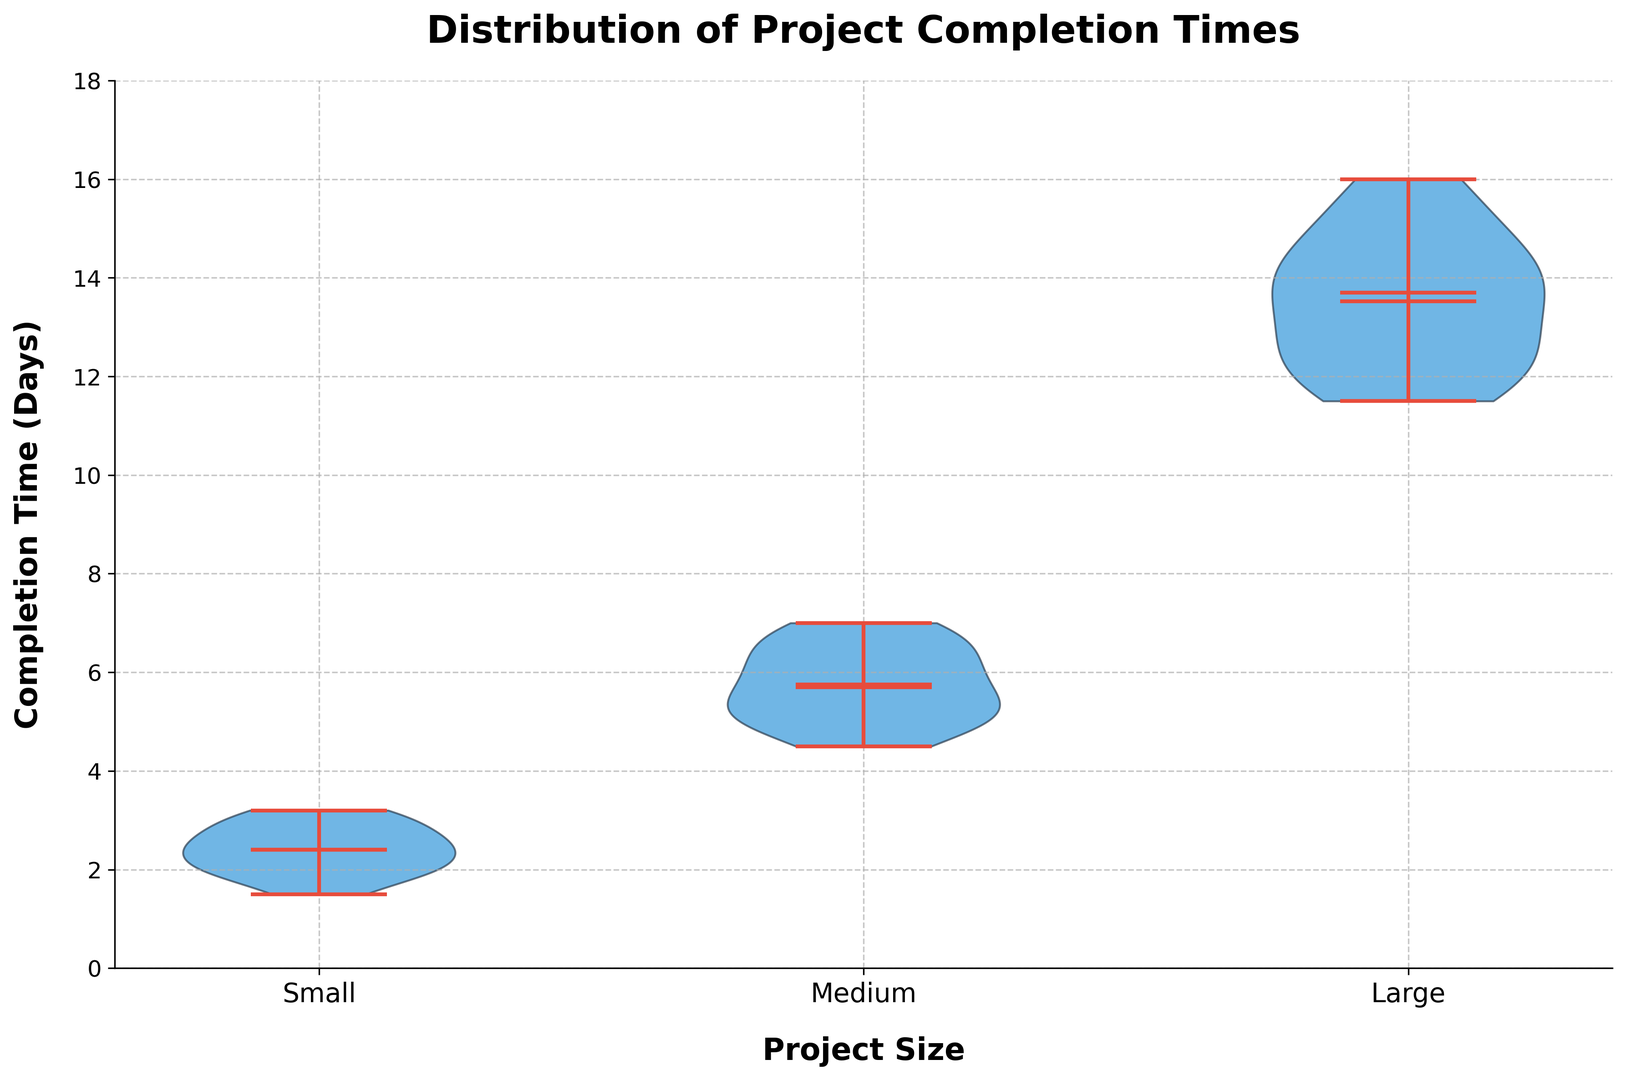What is the median completion time for medium-sized projects? The median is represented by the line shown in the middle of the distribution for medium-sized projects. This is visibly located around 6 days.
Answer: 6 Which project size has the greatest range in completion times? The range in completion times can be seen by looking at the length from the minimum to the maximum extent of each violin plot. The large-scale projects have the greatest range, spanning from around 11 to 16 days.
Answer: Large Are the mean and median completion times for small projects roughly equal? The mean is represented by a dot and the median by the line within the violin plot. For small projects, both indicators are placed very close to each other around 2.5 days, suggesting they are roughly equal.
Answer: Yes How do the completion times for medium projects compare to small projects in terms of variability? The variability can be seen by the spread of the violin plot. Medium projects have a wider spread than small projects, indicating greater variability in completion times.
Answer: Medium projects have greater variability Which project size has the smallest interquartile range (IQR)? The IQR can be visually approximated by the width of the middle part of the violin plot. Small-sized projects show a more concentrated, narrow middle region compared to medium and large projects, indicating a smaller IQR.
Answer: Small What can you conclude about the distribution shapes for each project size? Small projects have a roughly symmetric, normal-like distribution, medium projects have a slightly right-skewed distribution, and large projects have a multimodal distribution with a bimodal tendency.
Answer: Small: symmetric, Medium: right-skewed, Large: bimodal Compare the highest completion times for small and medium projects. The maximum completion time for small projects is around 3.2 days, while for medium projects, it is about 7 days.
Answer: Medium projects have a higher maximum How does the spread of completion times for large projects compare to that of small projects? The spread of completion times is shown by the width of the entire violin plot. Large projects have a much broader spread than small projects, indicating larger variability in completion times for large projects.
Answer: Large projects have a broader spread What percentage of small projects are completed under 2 days? The lower portion of the small projects' violin plot contains all the values under 2 days. Estimating by the density, roughly 2 out of 15 data points are below 2 days. Therefore, about 2/15 or roughly 13%.
Answer: 13% Are there any outliers in the completion times for large projects? Outliers would appear as small dots outside the range of the main distribution. There are no such dots for the large projects violin plot, indicating no significant outliers.
Answer: No 